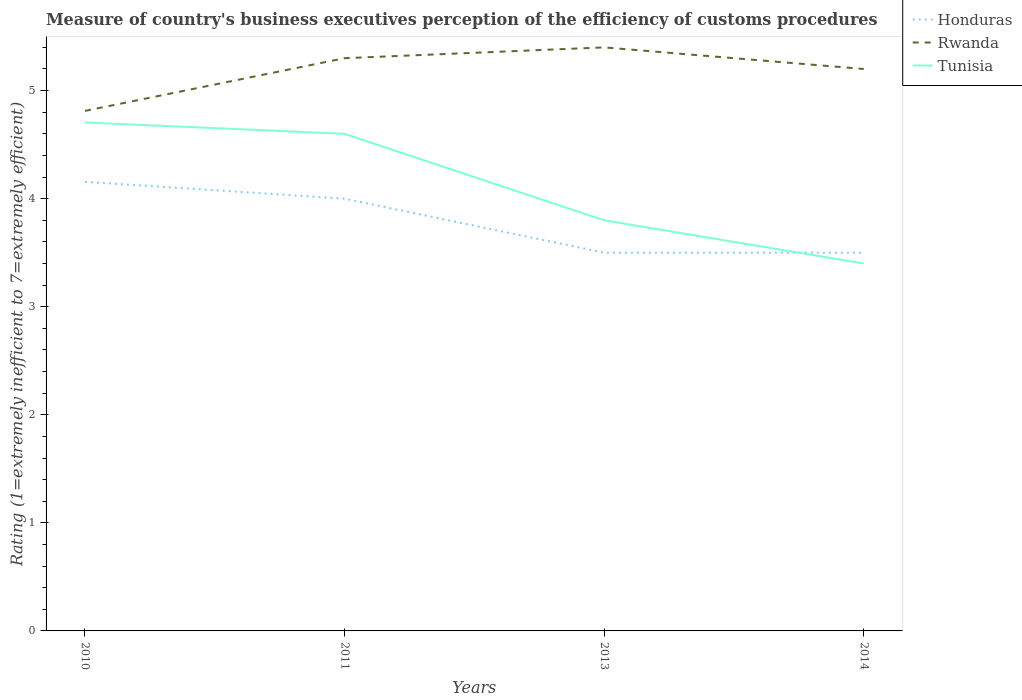How many different coloured lines are there?
Your answer should be compact. 3. Does the line corresponding to Rwanda intersect with the line corresponding to Tunisia?
Provide a short and direct response. No. Across all years, what is the maximum rating of the efficiency of customs procedure in Tunisia?
Your answer should be very brief. 3.4. What is the total rating of the efficiency of customs procedure in Rwanda in the graph?
Offer a terse response. -0.59. What is the difference between the highest and the second highest rating of the efficiency of customs procedure in Tunisia?
Provide a succinct answer. 1.31. How many lines are there?
Your answer should be compact. 3. How many years are there in the graph?
Your response must be concise. 4. What is the difference between two consecutive major ticks on the Y-axis?
Your answer should be very brief. 1. Are the values on the major ticks of Y-axis written in scientific E-notation?
Offer a very short reply. No. Does the graph contain any zero values?
Ensure brevity in your answer.  No. Does the graph contain grids?
Provide a succinct answer. No. Where does the legend appear in the graph?
Keep it short and to the point. Top right. How are the legend labels stacked?
Ensure brevity in your answer.  Vertical. What is the title of the graph?
Make the answer very short. Measure of country's business executives perception of the efficiency of customs procedures. What is the label or title of the X-axis?
Offer a terse response. Years. What is the label or title of the Y-axis?
Offer a terse response. Rating (1=extremely inefficient to 7=extremely efficient). What is the Rating (1=extremely inefficient to 7=extremely efficient) in Honduras in 2010?
Keep it short and to the point. 4.16. What is the Rating (1=extremely inefficient to 7=extremely efficient) in Rwanda in 2010?
Make the answer very short. 4.81. What is the Rating (1=extremely inefficient to 7=extremely efficient) in Tunisia in 2010?
Make the answer very short. 4.71. What is the Rating (1=extremely inefficient to 7=extremely efficient) of Honduras in 2011?
Offer a very short reply. 4. What is the Rating (1=extremely inefficient to 7=extremely efficient) of Rwanda in 2011?
Offer a terse response. 5.3. What is the Rating (1=extremely inefficient to 7=extremely efficient) in Honduras in 2013?
Keep it short and to the point. 3.5. What is the Rating (1=extremely inefficient to 7=extremely efficient) in Tunisia in 2013?
Keep it short and to the point. 3.8. What is the Rating (1=extremely inefficient to 7=extremely efficient) of Honduras in 2014?
Your answer should be very brief. 3.5. What is the Rating (1=extremely inefficient to 7=extremely efficient) in Rwanda in 2014?
Give a very brief answer. 5.2. What is the Rating (1=extremely inefficient to 7=extremely efficient) in Tunisia in 2014?
Provide a succinct answer. 3.4. Across all years, what is the maximum Rating (1=extremely inefficient to 7=extremely efficient) of Honduras?
Make the answer very short. 4.16. Across all years, what is the maximum Rating (1=extremely inefficient to 7=extremely efficient) in Rwanda?
Your answer should be very brief. 5.4. Across all years, what is the maximum Rating (1=extremely inefficient to 7=extremely efficient) in Tunisia?
Offer a very short reply. 4.71. Across all years, what is the minimum Rating (1=extremely inefficient to 7=extremely efficient) in Honduras?
Make the answer very short. 3.5. Across all years, what is the minimum Rating (1=extremely inefficient to 7=extremely efficient) in Rwanda?
Provide a succinct answer. 4.81. What is the total Rating (1=extremely inefficient to 7=extremely efficient) of Honduras in the graph?
Offer a terse response. 15.16. What is the total Rating (1=extremely inefficient to 7=extremely efficient) in Rwanda in the graph?
Provide a succinct answer. 20.71. What is the total Rating (1=extremely inefficient to 7=extremely efficient) in Tunisia in the graph?
Provide a short and direct response. 16.51. What is the difference between the Rating (1=extremely inefficient to 7=extremely efficient) of Honduras in 2010 and that in 2011?
Make the answer very short. 0.16. What is the difference between the Rating (1=extremely inefficient to 7=extremely efficient) of Rwanda in 2010 and that in 2011?
Provide a succinct answer. -0.49. What is the difference between the Rating (1=extremely inefficient to 7=extremely efficient) of Tunisia in 2010 and that in 2011?
Offer a very short reply. 0.11. What is the difference between the Rating (1=extremely inefficient to 7=extremely efficient) of Honduras in 2010 and that in 2013?
Keep it short and to the point. 0.66. What is the difference between the Rating (1=extremely inefficient to 7=extremely efficient) in Rwanda in 2010 and that in 2013?
Provide a short and direct response. -0.59. What is the difference between the Rating (1=extremely inefficient to 7=extremely efficient) in Tunisia in 2010 and that in 2013?
Provide a succinct answer. 0.91. What is the difference between the Rating (1=extremely inefficient to 7=extremely efficient) of Honduras in 2010 and that in 2014?
Provide a short and direct response. 0.66. What is the difference between the Rating (1=extremely inefficient to 7=extremely efficient) of Rwanda in 2010 and that in 2014?
Make the answer very short. -0.39. What is the difference between the Rating (1=extremely inefficient to 7=extremely efficient) of Tunisia in 2010 and that in 2014?
Offer a very short reply. 1.31. What is the difference between the Rating (1=extremely inefficient to 7=extremely efficient) of Rwanda in 2011 and that in 2013?
Provide a succinct answer. -0.1. What is the difference between the Rating (1=extremely inefficient to 7=extremely efficient) in Honduras in 2013 and that in 2014?
Your answer should be compact. 0. What is the difference between the Rating (1=extremely inefficient to 7=extremely efficient) of Rwanda in 2013 and that in 2014?
Make the answer very short. 0.2. What is the difference between the Rating (1=extremely inefficient to 7=extremely efficient) of Tunisia in 2013 and that in 2014?
Give a very brief answer. 0.4. What is the difference between the Rating (1=extremely inefficient to 7=extremely efficient) in Honduras in 2010 and the Rating (1=extremely inefficient to 7=extremely efficient) in Rwanda in 2011?
Provide a short and direct response. -1.14. What is the difference between the Rating (1=extremely inefficient to 7=extremely efficient) in Honduras in 2010 and the Rating (1=extremely inefficient to 7=extremely efficient) in Tunisia in 2011?
Your response must be concise. -0.44. What is the difference between the Rating (1=extremely inefficient to 7=extremely efficient) in Rwanda in 2010 and the Rating (1=extremely inefficient to 7=extremely efficient) in Tunisia in 2011?
Provide a short and direct response. 0.21. What is the difference between the Rating (1=extremely inefficient to 7=extremely efficient) of Honduras in 2010 and the Rating (1=extremely inefficient to 7=extremely efficient) of Rwanda in 2013?
Make the answer very short. -1.24. What is the difference between the Rating (1=extremely inefficient to 7=extremely efficient) in Honduras in 2010 and the Rating (1=extremely inefficient to 7=extremely efficient) in Tunisia in 2013?
Give a very brief answer. 0.36. What is the difference between the Rating (1=extremely inefficient to 7=extremely efficient) of Rwanda in 2010 and the Rating (1=extremely inefficient to 7=extremely efficient) of Tunisia in 2013?
Provide a succinct answer. 1.01. What is the difference between the Rating (1=extremely inefficient to 7=extremely efficient) in Honduras in 2010 and the Rating (1=extremely inefficient to 7=extremely efficient) in Rwanda in 2014?
Your answer should be compact. -1.04. What is the difference between the Rating (1=extremely inefficient to 7=extremely efficient) of Honduras in 2010 and the Rating (1=extremely inefficient to 7=extremely efficient) of Tunisia in 2014?
Ensure brevity in your answer.  0.76. What is the difference between the Rating (1=extremely inefficient to 7=extremely efficient) of Rwanda in 2010 and the Rating (1=extremely inefficient to 7=extremely efficient) of Tunisia in 2014?
Give a very brief answer. 1.41. What is the difference between the Rating (1=extremely inefficient to 7=extremely efficient) of Honduras in 2011 and the Rating (1=extremely inefficient to 7=extremely efficient) of Rwanda in 2013?
Your answer should be compact. -1.4. What is the difference between the Rating (1=extremely inefficient to 7=extremely efficient) of Honduras in 2011 and the Rating (1=extremely inefficient to 7=extremely efficient) of Rwanda in 2014?
Offer a very short reply. -1.2. What is the difference between the Rating (1=extremely inefficient to 7=extremely efficient) in Rwanda in 2011 and the Rating (1=extremely inefficient to 7=extremely efficient) in Tunisia in 2014?
Provide a short and direct response. 1.9. What is the difference between the Rating (1=extremely inefficient to 7=extremely efficient) of Honduras in 2013 and the Rating (1=extremely inefficient to 7=extremely efficient) of Rwanda in 2014?
Keep it short and to the point. -1.7. What is the average Rating (1=extremely inefficient to 7=extremely efficient) in Honduras per year?
Give a very brief answer. 3.79. What is the average Rating (1=extremely inefficient to 7=extremely efficient) in Rwanda per year?
Your response must be concise. 5.18. What is the average Rating (1=extremely inefficient to 7=extremely efficient) in Tunisia per year?
Keep it short and to the point. 4.13. In the year 2010, what is the difference between the Rating (1=extremely inefficient to 7=extremely efficient) of Honduras and Rating (1=extremely inefficient to 7=extremely efficient) of Rwanda?
Your response must be concise. -0.66. In the year 2010, what is the difference between the Rating (1=extremely inefficient to 7=extremely efficient) in Honduras and Rating (1=extremely inefficient to 7=extremely efficient) in Tunisia?
Your answer should be compact. -0.55. In the year 2010, what is the difference between the Rating (1=extremely inefficient to 7=extremely efficient) of Rwanda and Rating (1=extremely inefficient to 7=extremely efficient) of Tunisia?
Provide a succinct answer. 0.11. In the year 2011, what is the difference between the Rating (1=extremely inefficient to 7=extremely efficient) in Rwanda and Rating (1=extremely inefficient to 7=extremely efficient) in Tunisia?
Offer a terse response. 0.7. In the year 2013, what is the difference between the Rating (1=extremely inefficient to 7=extremely efficient) in Honduras and Rating (1=extremely inefficient to 7=extremely efficient) in Rwanda?
Offer a terse response. -1.9. In the year 2013, what is the difference between the Rating (1=extremely inefficient to 7=extremely efficient) in Rwanda and Rating (1=extremely inefficient to 7=extremely efficient) in Tunisia?
Give a very brief answer. 1.6. In the year 2014, what is the difference between the Rating (1=extremely inefficient to 7=extremely efficient) of Honduras and Rating (1=extremely inefficient to 7=extremely efficient) of Rwanda?
Keep it short and to the point. -1.7. In the year 2014, what is the difference between the Rating (1=extremely inefficient to 7=extremely efficient) in Honduras and Rating (1=extremely inefficient to 7=extremely efficient) in Tunisia?
Offer a terse response. 0.1. What is the ratio of the Rating (1=extremely inefficient to 7=extremely efficient) in Honduras in 2010 to that in 2011?
Ensure brevity in your answer.  1.04. What is the ratio of the Rating (1=extremely inefficient to 7=extremely efficient) of Rwanda in 2010 to that in 2011?
Keep it short and to the point. 0.91. What is the ratio of the Rating (1=extremely inefficient to 7=extremely efficient) of Tunisia in 2010 to that in 2011?
Ensure brevity in your answer.  1.02. What is the ratio of the Rating (1=extremely inefficient to 7=extremely efficient) in Honduras in 2010 to that in 2013?
Ensure brevity in your answer.  1.19. What is the ratio of the Rating (1=extremely inefficient to 7=extremely efficient) of Rwanda in 2010 to that in 2013?
Give a very brief answer. 0.89. What is the ratio of the Rating (1=extremely inefficient to 7=extremely efficient) in Tunisia in 2010 to that in 2013?
Your answer should be very brief. 1.24. What is the ratio of the Rating (1=extremely inefficient to 7=extremely efficient) in Honduras in 2010 to that in 2014?
Your answer should be compact. 1.19. What is the ratio of the Rating (1=extremely inefficient to 7=extremely efficient) of Rwanda in 2010 to that in 2014?
Make the answer very short. 0.93. What is the ratio of the Rating (1=extremely inefficient to 7=extremely efficient) of Tunisia in 2010 to that in 2014?
Keep it short and to the point. 1.38. What is the ratio of the Rating (1=extremely inefficient to 7=extremely efficient) of Honduras in 2011 to that in 2013?
Offer a terse response. 1.14. What is the ratio of the Rating (1=extremely inefficient to 7=extremely efficient) of Rwanda in 2011 to that in 2013?
Your answer should be very brief. 0.98. What is the ratio of the Rating (1=extremely inefficient to 7=extremely efficient) in Tunisia in 2011 to that in 2013?
Your answer should be compact. 1.21. What is the ratio of the Rating (1=extremely inefficient to 7=extremely efficient) of Honduras in 2011 to that in 2014?
Keep it short and to the point. 1.14. What is the ratio of the Rating (1=extremely inefficient to 7=extremely efficient) in Rwanda in 2011 to that in 2014?
Offer a very short reply. 1.02. What is the ratio of the Rating (1=extremely inefficient to 7=extremely efficient) of Tunisia in 2011 to that in 2014?
Your answer should be compact. 1.35. What is the ratio of the Rating (1=extremely inefficient to 7=extremely efficient) of Rwanda in 2013 to that in 2014?
Offer a very short reply. 1.04. What is the ratio of the Rating (1=extremely inefficient to 7=extremely efficient) in Tunisia in 2013 to that in 2014?
Offer a very short reply. 1.12. What is the difference between the highest and the second highest Rating (1=extremely inefficient to 7=extremely efficient) of Honduras?
Your response must be concise. 0.16. What is the difference between the highest and the second highest Rating (1=extremely inefficient to 7=extremely efficient) in Rwanda?
Give a very brief answer. 0.1. What is the difference between the highest and the second highest Rating (1=extremely inefficient to 7=extremely efficient) in Tunisia?
Offer a very short reply. 0.11. What is the difference between the highest and the lowest Rating (1=extremely inefficient to 7=extremely efficient) of Honduras?
Provide a succinct answer. 0.66. What is the difference between the highest and the lowest Rating (1=extremely inefficient to 7=extremely efficient) of Rwanda?
Provide a succinct answer. 0.59. What is the difference between the highest and the lowest Rating (1=extremely inefficient to 7=extremely efficient) of Tunisia?
Offer a terse response. 1.31. 